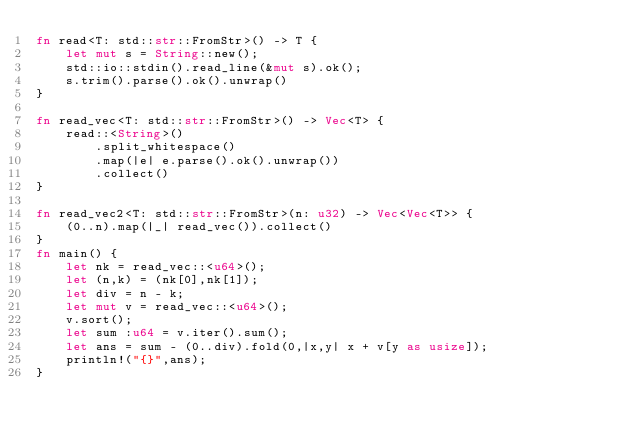<code> <loc_0><loc_0><loc_500><loc_500><_Rust_>fn read<T: std::str::FromStr>() -> T {
    let mut s = String::new();
    std::io::stdin().read_line(&mut s).ok();
    s.trim().parse().ok().unwrap()
}

fn read_vec<T: std::str::FromStr>() -> Vec<T> {
    read::<String>()
        .split_whitespace()
        .map(|e| e.parse().ok().unwrap())
        .collect()
}

fn read_vec2<T: std::str::FromStr>(n: u32) -> Vec<Vec<T>> {
    (0..n).map(|_| read_vec()).collect()
}
fn main() {
    let nk = read_vec::<u64>();
    let (n,k) = (nk[0],nk[1]);
    let div = n - k;
    let mut v = read_vec::<u64>();
    v.sort();
    let sum :u64 = v.iter().sum();
    let ans = sum - (0..div).fold(0,|x,y| x + v[y as usize]);
    println!("{}",ans);
}</code> 